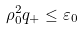Convert formula to latex. <formula><loc_0><loc_0><loc_500><loc_500>\rho _ { 0 } ^ { 2 } q _ { + } \leq \varepsilon _ { 0 }</formula> 